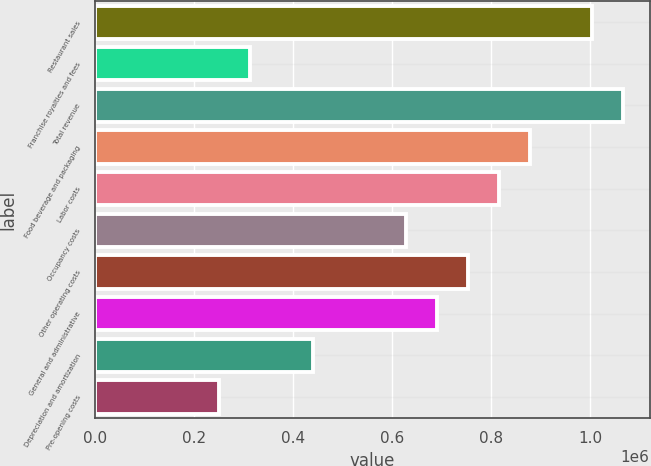<chart> <loc_0><loc_0><loc_500><loc_500><bar_chart><fcel>Restaurant sales<fcel>Franchise royalties and fees<fcel>Total revenue<fcel>Food beverage and packaging<fcel>Labor costs<fcel>Occupancy costs<fcel>Other operating costs<fcel>General and administrative<fcel>Depreciation and amortization<fcel>Pre-opening costs<nl><fcel>1.00431e+06<fcel>313848<fcel>1.06708e+06<fcel>878772<fcel>816003<fcel>627695<fcel>753234<fcel>690464<fcel>439387<fcel>251079<nl></chart> 